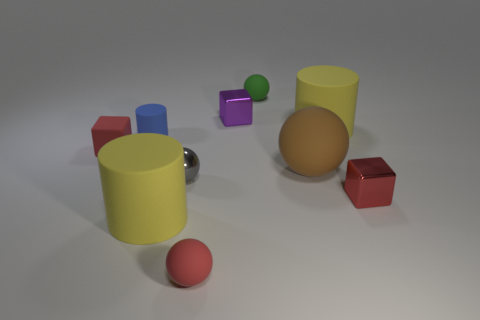Subtract all cylinders. How many objects are left? 7 Add 1 small red blocks. How many small red blocks are left? 3 Add 7 red objects. How many red objects exist? 10 Subtract 0 blue blocks. How many objects are left? 10 Subtract all big blue cylinders. Subtract all tiny purple blocks. How many objects are left? 9 